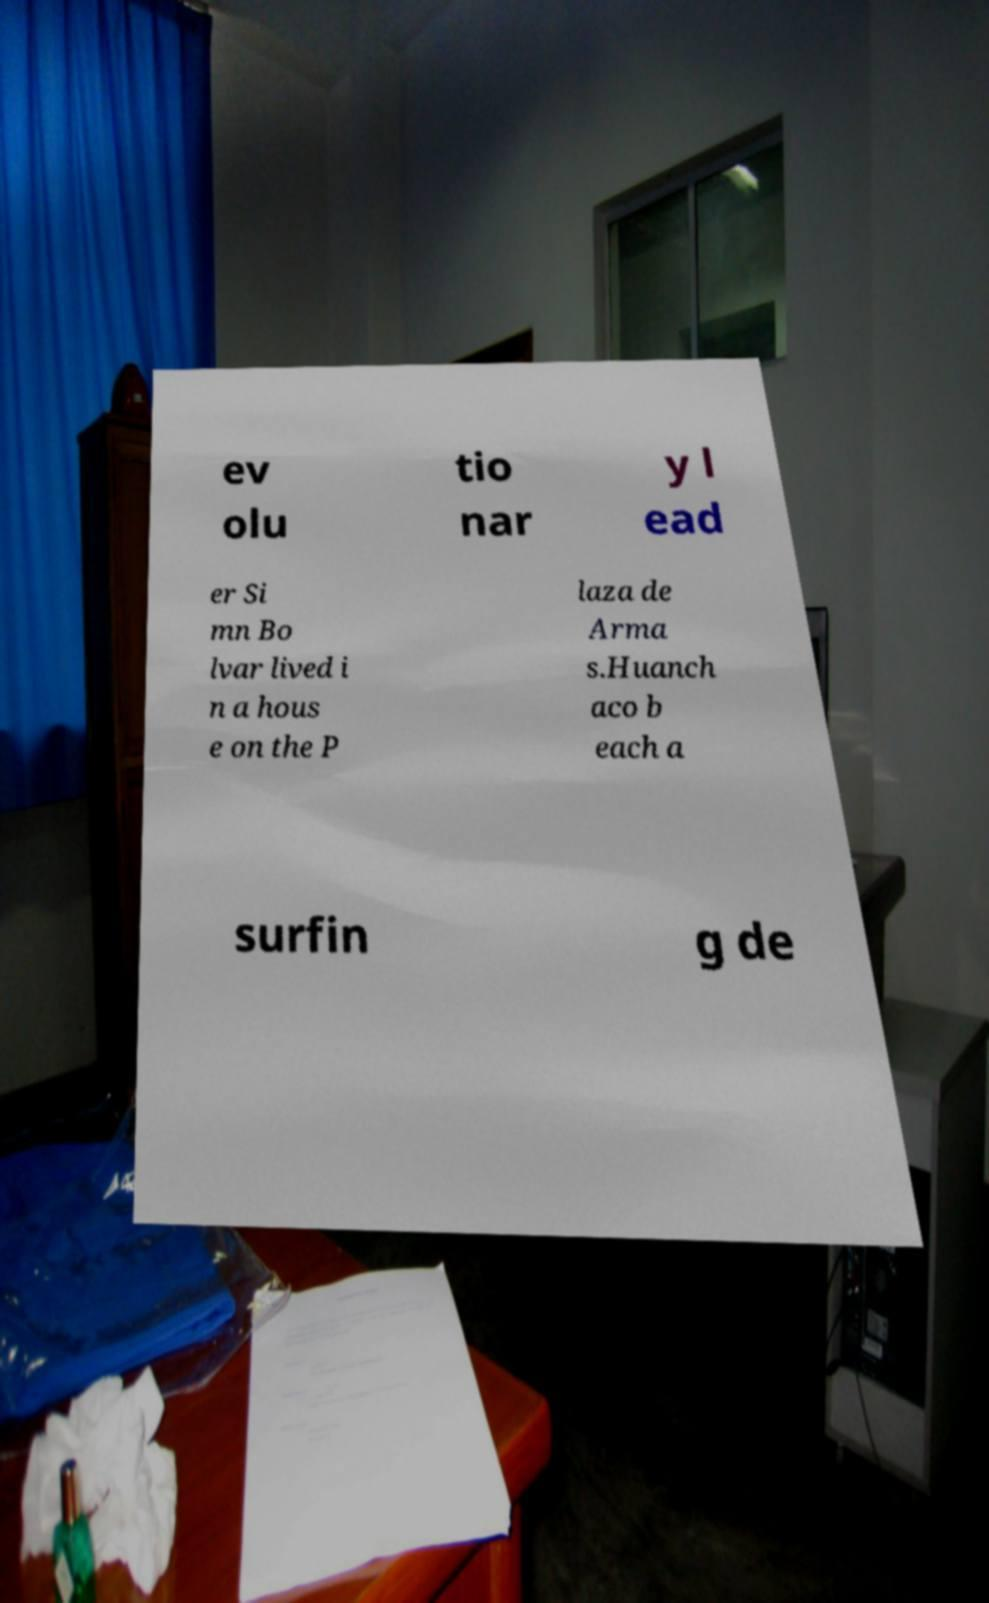Please identify and transcribe the text found in this image. ev olu tio nar y l ead er Si mn Bo lvar lived i n a hous e on the P laza de Arma s.Huanch aco b each a surfin g de 